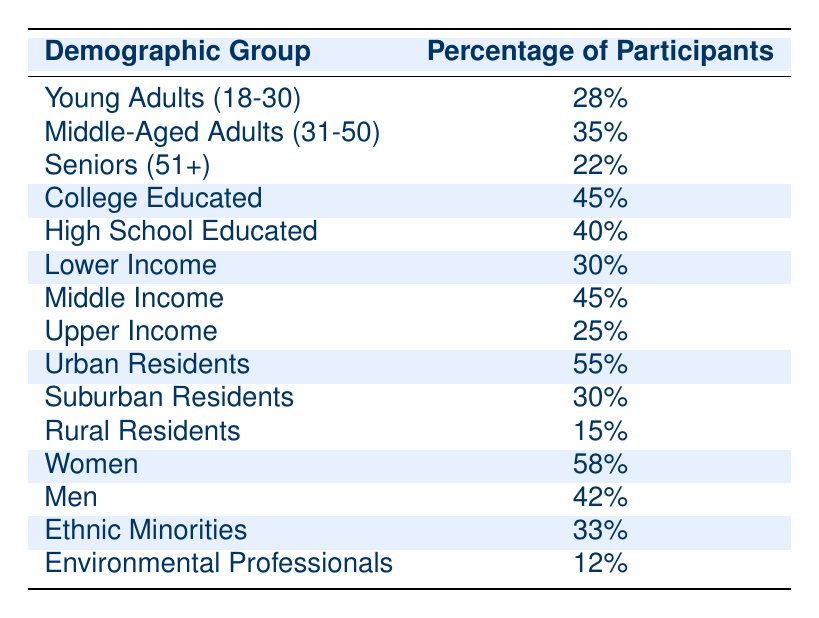What percentage of participants are seniors (51+)? The table explicitly lists the percentage of seniors in the demographic breakdown, which is noted as 22%.
Answer: 22% Which demographic group has the highest percentage of participants? By scanning the table, it is clear that 'Women' have the highest percentage of participants at 58%.
Answer: 58% What is the difference in the percentage of college-educated participants compared to upper-income participants? The percentage of college-educated participants is 45% and that of upper-income participants is 25%. The difference is 45% - 25% = 20%.
Answer: 20% Are there more urban residents or rural residents participating in the programs? Urban residents have a participation percentage of 55%, while rural residents are at 15%. Since 55% is greater than 15%, there are more urban residents.
Answer: Yes What is the combined percentage of middle-aged adults (31-50) and seniors (51+) participating in the programs? The percentage of middle-aged participants is 35% and seniors is 22%. Summing these gives us 35% + 22% = 57%.
Answer: 57% What percentage of participants are either lower-income or upper-income? Lower-income participants make up 30% and upper-income participants account for 25%. Adding these percentages, 30% + 25% = 55%.
Answer: 55% What is the average percentage of participants for those who are college and high school educated? The college-educated percentage is 45% and high school-educated is 40%. To find the average, we sum them (45% + 40% = 85%) and divide by 2, giving 85%/2 = 42.5%.
Answer: 42.5% Are there more men or women participating in these programs? The table shows that 58% of participants are women and 42% are men. Since 58% is greater than 42%, there are more women participating.
Answer: Yes What percentage of participants belongs to ethnic minorities? According to the table, the percentage of participants who are ethnic minorities is 33%.
Answer: 33% 